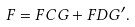Convert formula to latex. <formula><loc_0><loc_0><loc_500><loc_500>F = F C G + F D G ^ { \prime } .</formula> 